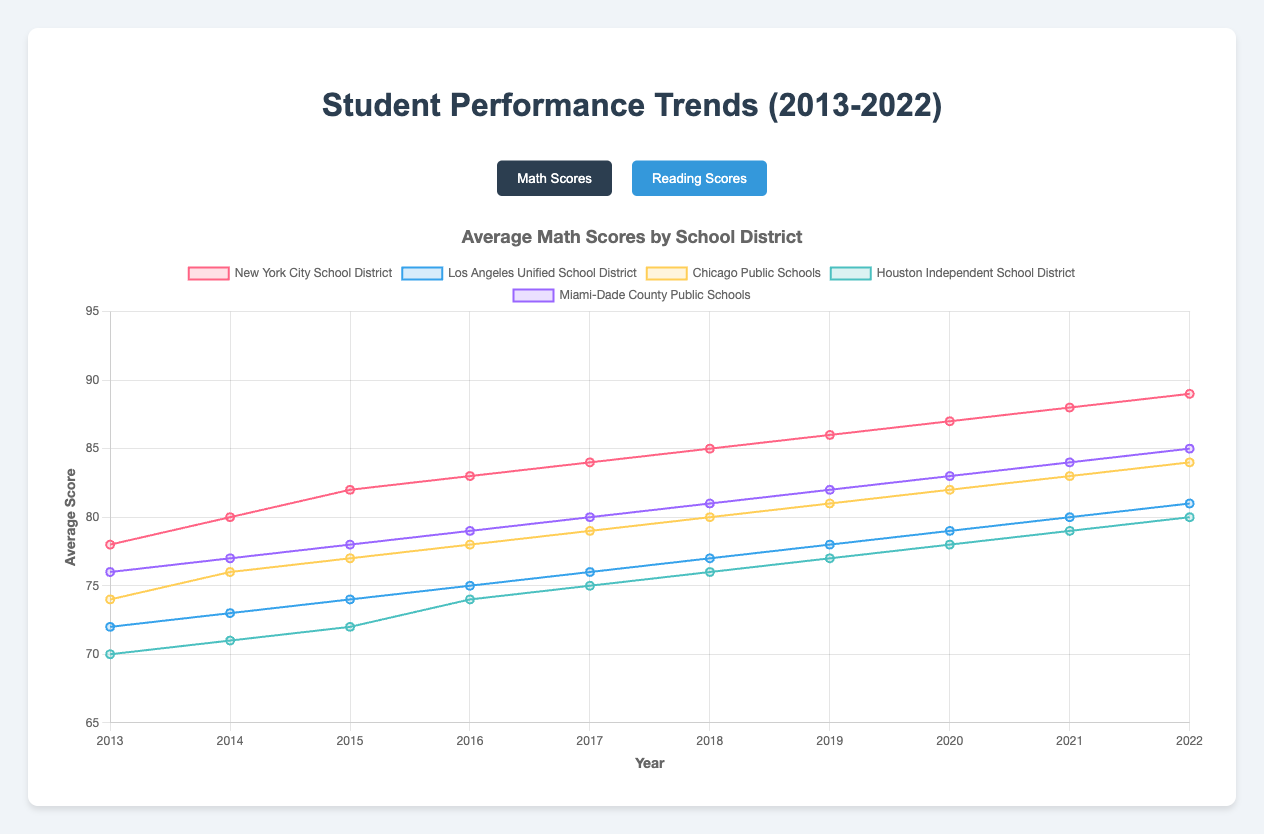Which school district had the highest average math score in 2022? Look at the end of the math scores lines; the New York City School District line is the highest, showing 89.
Answer: New York City School District How did the average math scores for Los Angeles Unified School District change from 2013 to 2022? Find the beginning and end values of Los Angeles Unified School District's math scores: 72 in 2013 and 81 in 2022. Calculate the difference: 81 - 72 = 9.
Answer: Increased by 9 Between New York City School District and Miami-Dade County Public Schools, which one had a larger increase in average reading scores over the decade? Compare score increases: New York City (85 - 75 = 10) and Miami-Dade (83 - 74 = 9). New York City had a 10-point increase, Miami-Dade had a 9-point increase.
Answer: New York City School District Which school district consistently ranked the lowest in average math scores throughout the decade? Look at the trend lines of all districts. Houston Independent School District always has the lowest point compared to others.
Answer: Houston Independent School District What is the difference between the average math scores of New York City School District and Chicago Public Schools in 2022? Note the 2022 math scores: New York City (89) and Chicago (84). Calculate the difference: 89 - 84 = 5.
Answer: 5 Which school district had the smallest difference between their average math and reading scores in 2022? Compare the differences: New York City (89-85=4), Los Angeles (81-78=3), Chicago (84-81=3), Houston (80-77=3), Miami-Dade (85-83=2). Miami-Dade has the smallest difference of 2.
Answer: Miami-Dade County Public Schools In which year did Chicago Public Schools' average reading scores surpass 75 for the first time? Follow the reading scores line to where it first exceeds 75. It crosses 75 between 2014 and 2015.
Answer: 2015 Which school district had the most gradual improvement in average math scores over the period? Compare the slopes of the lines. Los Angeles Unified School District's line is the flattest, showing the most gradual increase.
Answer: Los Angeles Unified School District What was the average reading score for Houston Independent School District in 2016? Look at Houston's reading score in 2016, which is 71.
Answer: 71 